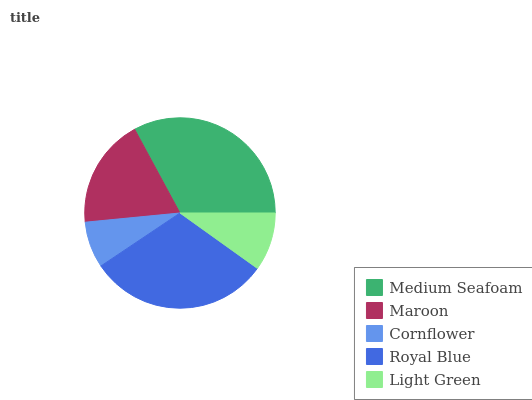Is Cornflower the minimum?
Answer yes or no. Yes. Is Medium Seafoam the maximum?
Answer yes or no. Yes. Is Maroon the minimum?
Answer yes or no. No. Is Maroon the maximum?
Answer yes or no. No. Is Medium Seafoam greater than Maroon?
Answer yes or no. Yes. Is Maroon less than Medium Seafoam?
Answer yes or no. Yes. Is Maroon greater than Medium Seafoam?
Answer yes or no. No. Is Medium Seafoam less than Maroon?
Answer yes or no. No. Is Maroon the high median?
Answer yes or no. Yes. Is Maroon the low median?
Answer yes or no. Yes. Is Light Green the high median?
Answer yes or no. No. Is Light Green the low median?
Answer yes or no. No. 